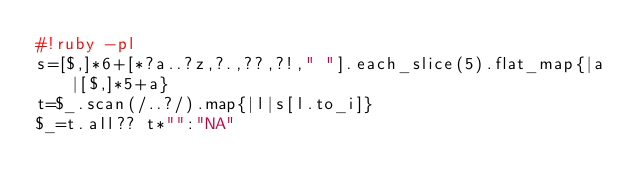Convert code to text. <code><loc_0><loc_0><loc_500><loc_500><_Ruby_>#!ruby -pl
s=[$,]*6+[*?a..?z,?.,??,?!," "].each_slice(5).flat_map{|a|[$,]*5+a}
t=$_.scan(/..?/).map{|l|s[l.to_i]}
$_=t.all?? t*"":"NA"</code> 